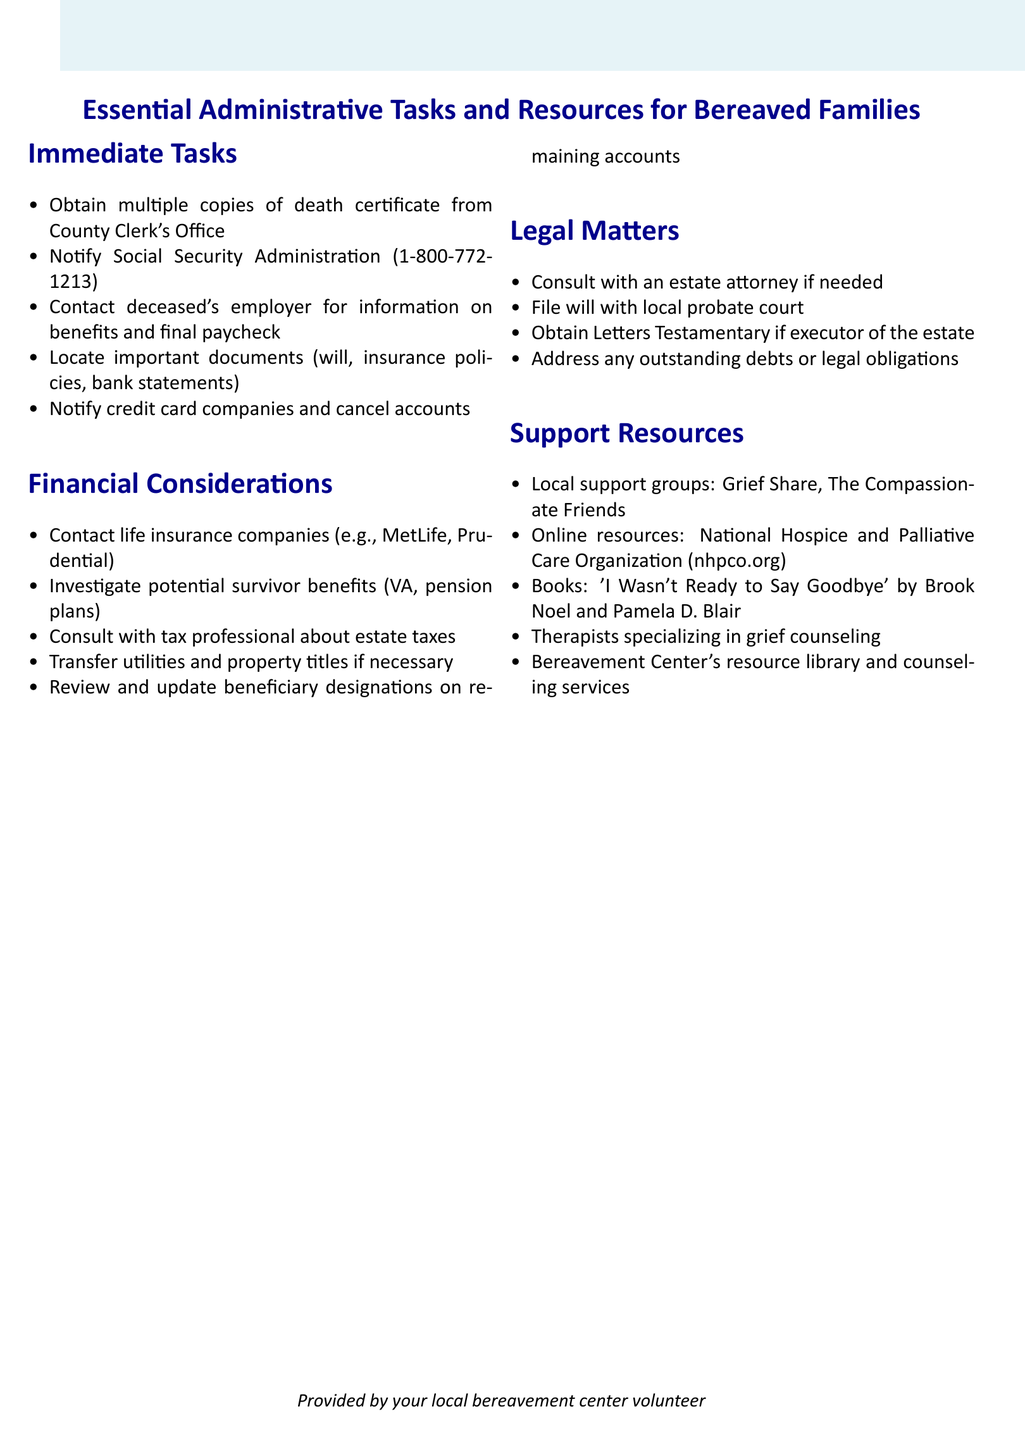What is the first immediate task listed? The first immediate task listed in the document is the one that mentions obtaining copies of the death certificate.
Answer: Obtain multiple copies of death certificate from County Clerk's Office What is the phone number for the Social Security Administration? The document provides a specific phone number for the Social Security Administration.
Answer: 1-800-772-1213 Name one support resource mentioned. The document lists several local support groups and resources, and asking for one of them is useful.
Answer: Grief Share What should you do if you are the executor of the estate? The document specifies the action related to the role of an executor in the legal matters section.
Answer: Obtain Letters Testamentary if executor of the estate Which insurance companies should be contacted? The document lists examples of life insurance companies to contact for benefits.
Answer: MetLife, Prudential What is a necessary financial consideration regarding utilities? The document highlights the action to take concerning utilities after a loss.
Answer: Transfer utilities and property titles if necessary What book is suggested for grief support? The document includes a specific book title for grieving individuals looking for support.
Answer: 'I Wasn't Ready to Say Goodbye' by Brook Noel and Pamela D. Blair How many sections are there in the document? The question is about the total number of sections covering various tasks and resources for bereaved families.
Answer: Four 